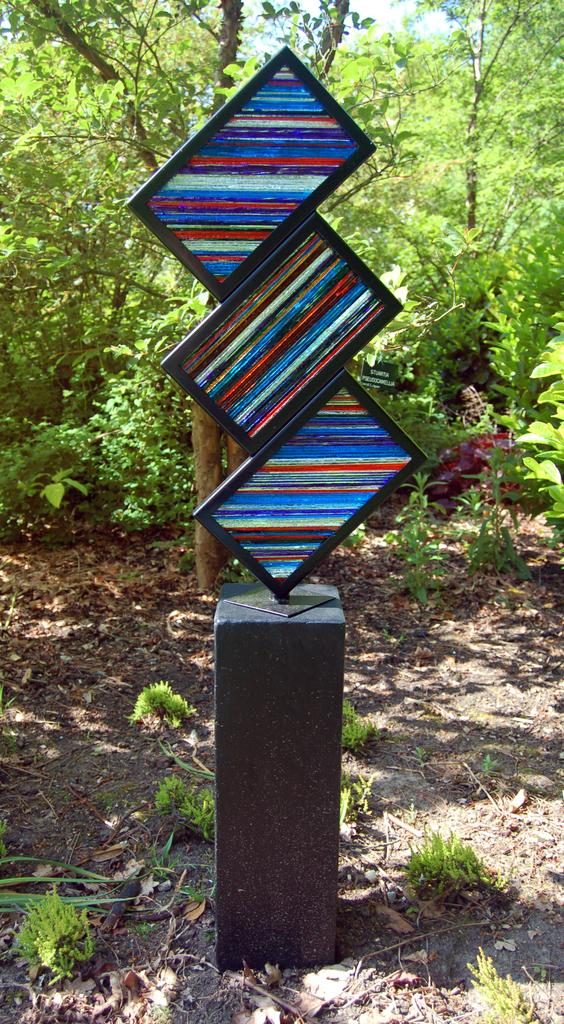What objects are present in the image? There are boards in the image. What can be seen in the background of the image? There are trees visible in the background of the image. What type of fish can be seen swimming near the boards in the image? There are no fish present in the image; it only features boards and trees in the background. What invention is being demonstrated with the boards in the image? There is no invention being demonstrated with the boards in the image. What degree is being awarded to the person standing near the boards in the image? There is no person or degree present in the image. 